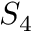<formula> <loc_0><loc_0><loc_500><loc_500>S _ { 4 }</formula> 